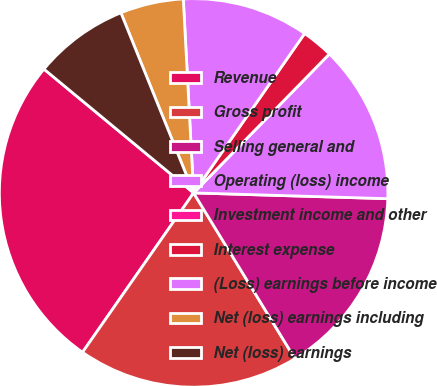<chart> <loc_0><loc_0><loc_500><loc_500><pie_chart><fcel>Revenue<fcel>Gross profit<fcel>Selling general and<fcel>Operating (loss) income<fcel>Investment income and other<fcel>Interest expense<fcel>(Loss) earnings before income<fcel>Net (loss) earnings including<fcel>Net (loss) earnings<nl><fcel>26.31%<fcel>18.42%<fcel>15.79%<fcel>13.16%<fcel>0.0%<fcel>2.63%<fcel>10.53%<fcel>5.26%<fcel>7.89%<nl></chart> 